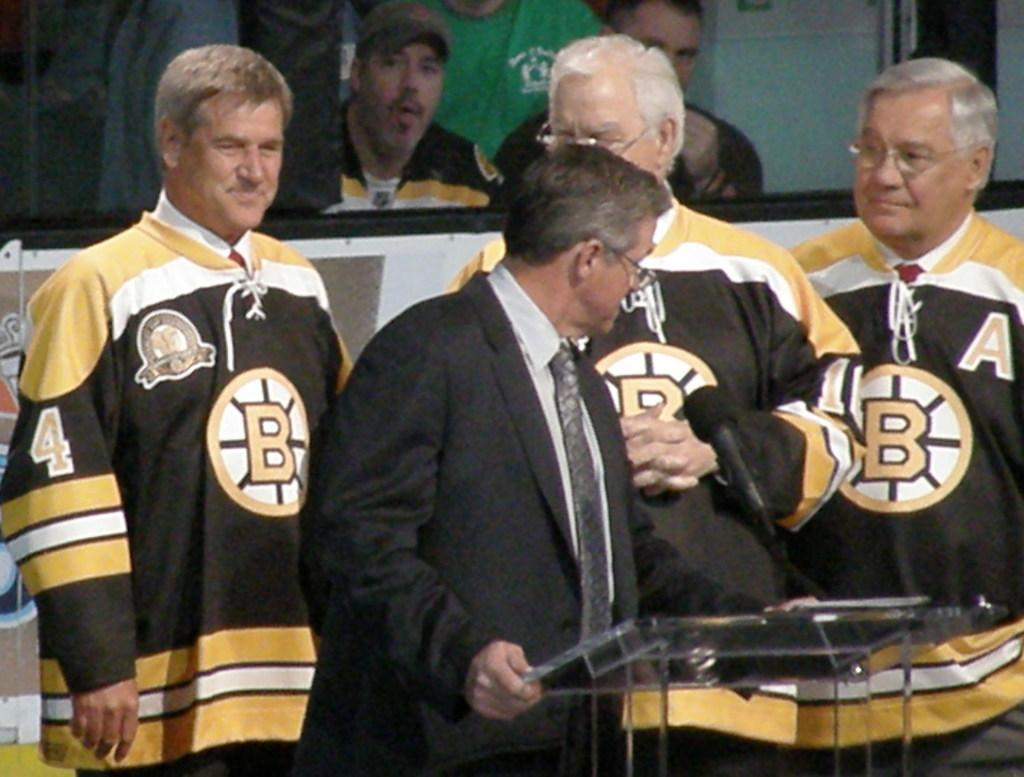<image>
Give a short and clear explanation of the subsequent image. men wearing bruin jerseys, one of them specifically with the number 4 